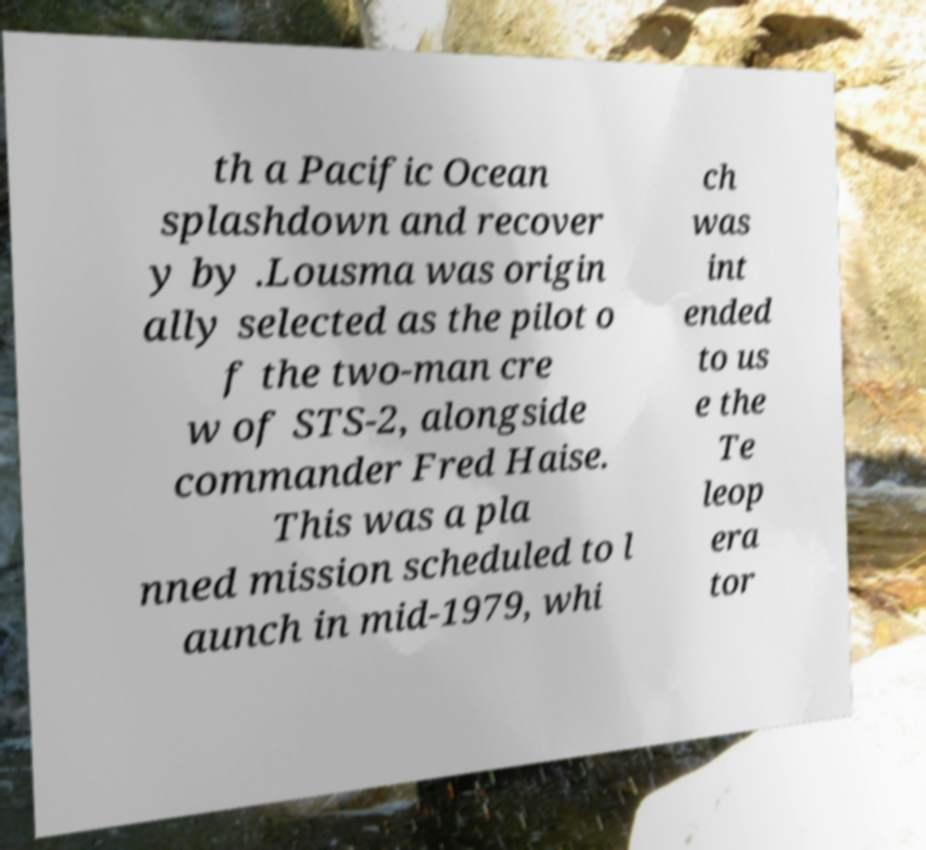For documentation purposes, I need the text within this image transcribed. Could you provide that? th a Pacific Ocean splashdown and recover y by .Lousma was origin ally selected as the pilot o f the two-man cre w of STS-2, alongside commander Fred Haise. This was a pla nned mission scheduled to l aunch in mid-1979, whi ch was int ended to us e the Te leop era tor 